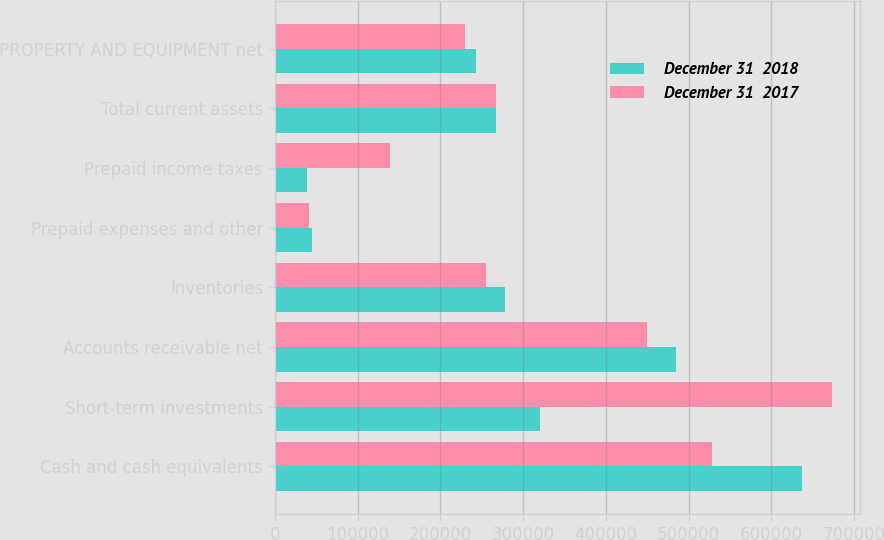Convert chart. <chart><loc_0><loc_0><loc_500><loc_500><stacked_bar_chart><ecel><fcel>Cash and cash equivalents<fcel>Short-term investments<fcel>Accounts receivable net<fcel>Inventories<fcel>Prepaid expenses and other<fcel>Prepaid income taxes<fcel>Total current assets<fcel>PROPERTY AND EQUIPMENT net<nl><fcel>December 31  2018<fcel>637513<fcel>320650<fcel>484562<fcel>277705<fcel>44909<fcel>38831<fcel>266725<fcel>243051<nl><fcel>December 31  2017<fcel>528622<fcel>672933<fcel>449476<fcel>255745<fcel>40877<fcel>138724<fcel>266725<fcel>230276<nl></chart> 